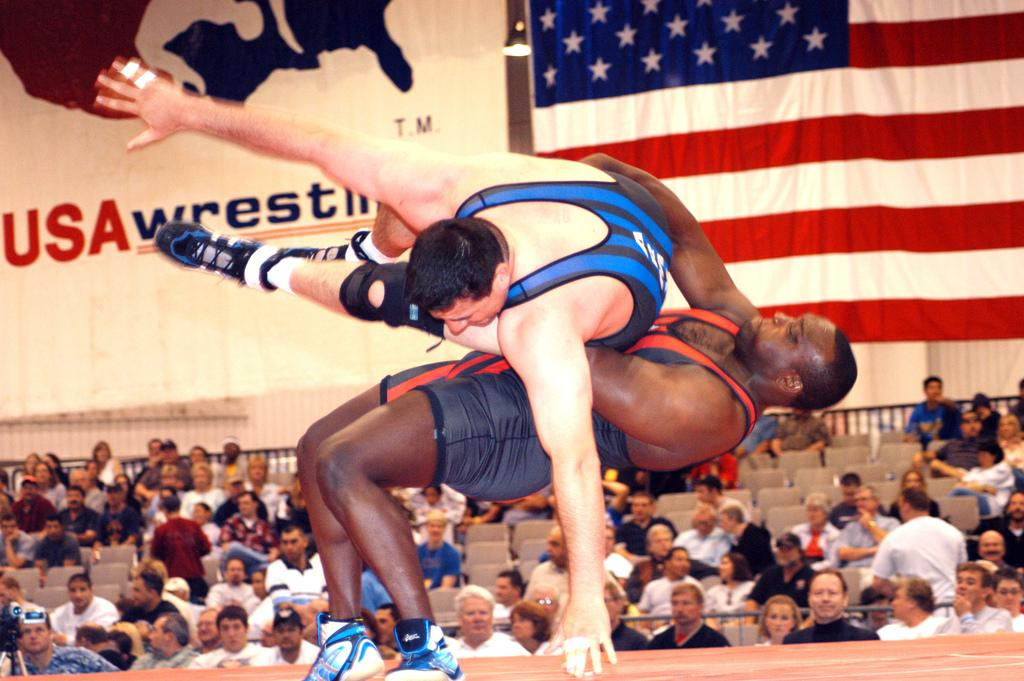<image>
Render a clear and concise summary of the photo. a person throwing another one down with usawrestling in the back 